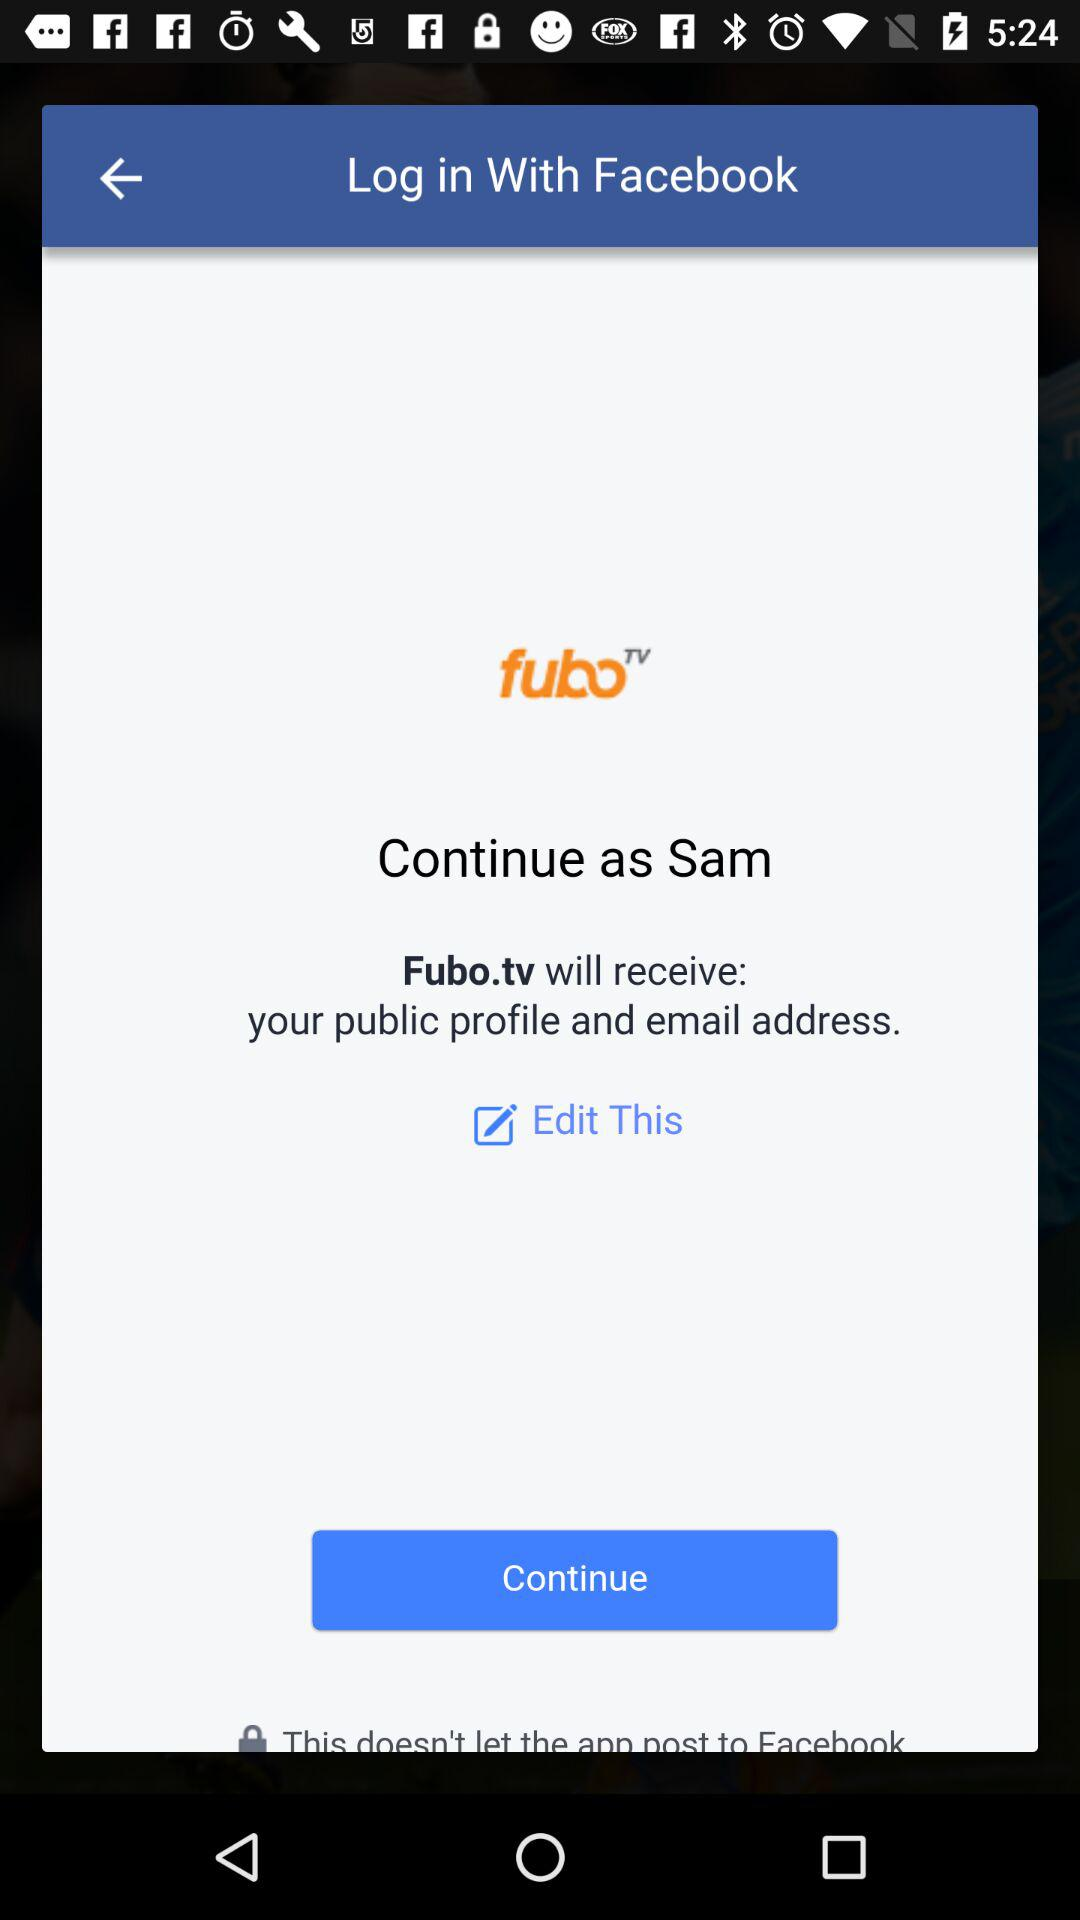What is the name of the user? The name of the user is Sam. 